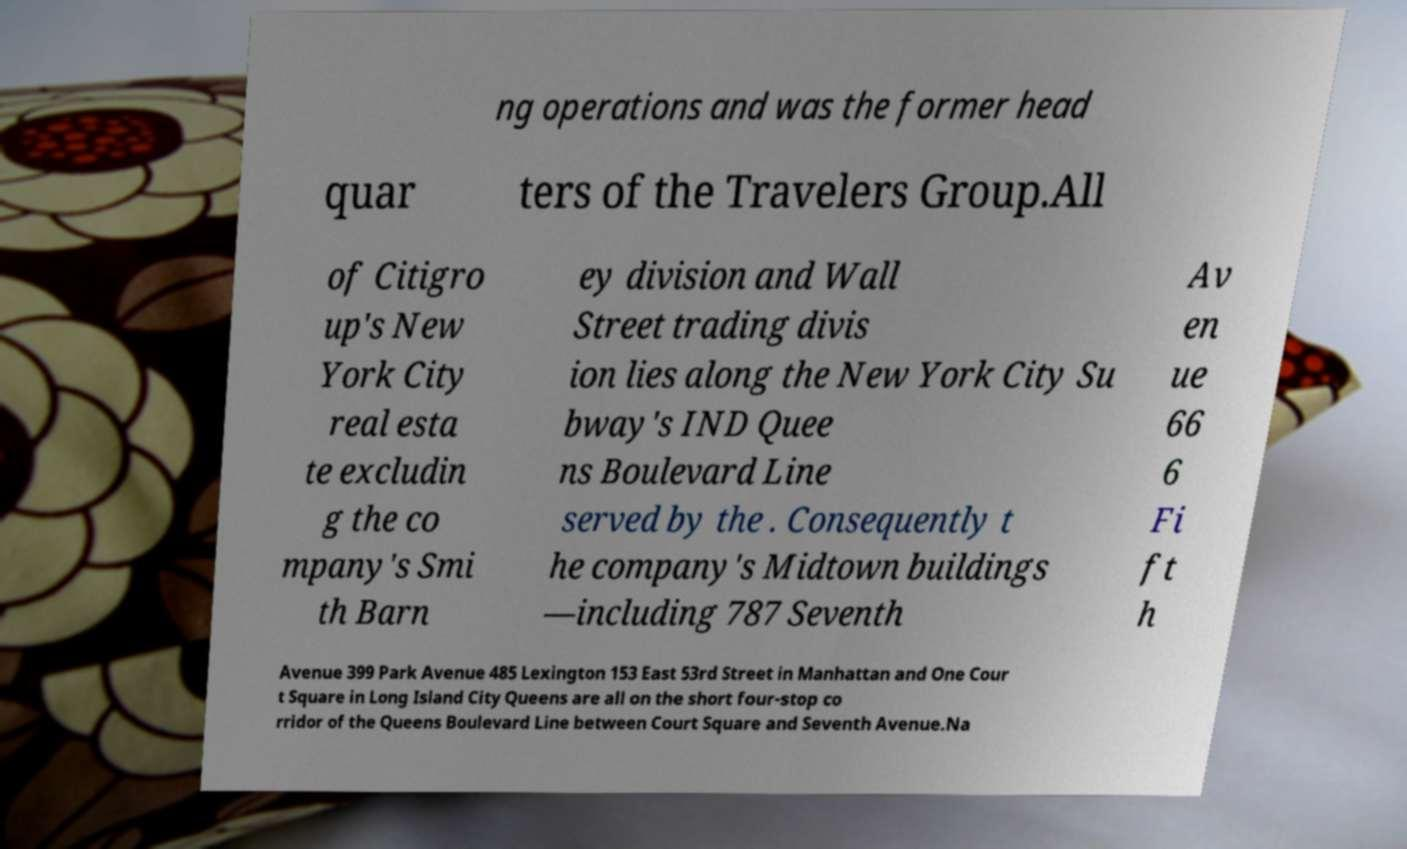What messages or text are displayed in this image? I need them in a readable, typed format. ng operations and was the former head quar ters of the Travelers Group.All of Citigro up's New York City real esta te excludin g the co mpany's Smi th Barn ey division and Wall Street trading divis ion lies along the New York City Su bway's IND Quee ns Boulevard Line served by the . Consequently t he company's Midtown buildings —including 787 Seventh Av en ue 66 6 Fi ft h Avenue 399 Park Avenue 485 Lexington 153 East 53rd Street in Manhattan and One Cour t Square in Long Island City Queens are all on the short four-stop co rridor of the Queens Boulevard Line between Court Square and Seventh Avenue.Na 